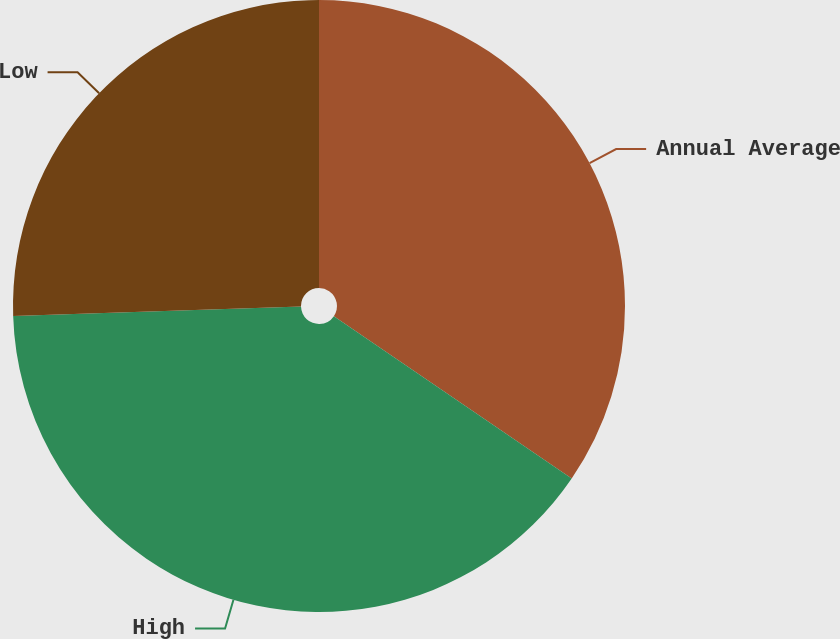Convert chart. <chart><loc_0><loc_0><loc_500><loc_500><pie_chart><fcel>Annual Average<fcel>High<fcel>Low<nl><fcel>34.54%<fcel>39.95%<fcel>25.52%<nl></chart> 